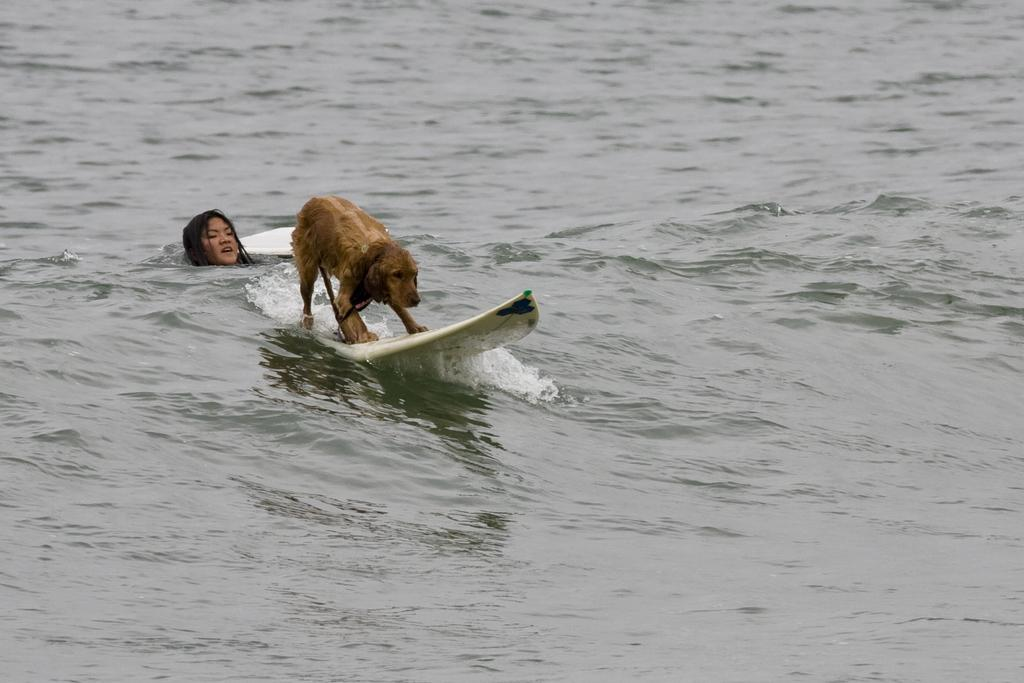What is the dog doing in the image? There is a dog on a surfboard in the image. What is the woman doing in the image? There is a woman swimming in the water in the image. What can be seen in the background of the image? There is water visible in the background of the image. What direction is the dog's wing pointing in the image? There is no wing present on the dog or in the image. What is the dog's temper like in the image? The dog's temper cannot be determined from the image, as it is a photograph and does not convey emotions. 